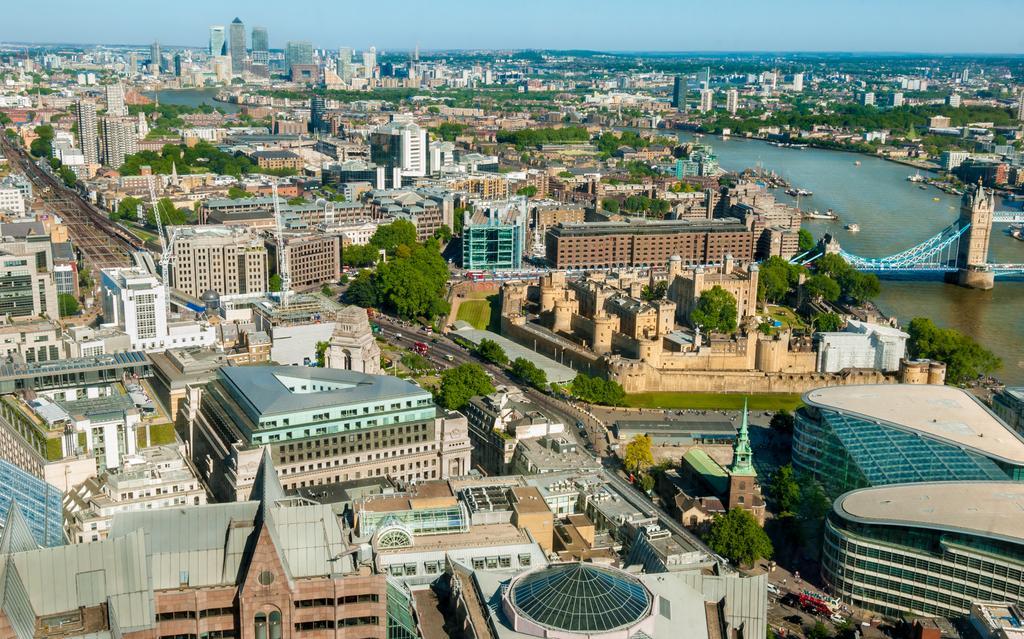How would you summarize this image in a sentence or two? This image is taken outdoors. At the top of the image there is the sky. In the middle of the image there are many buildings, houses and architectures. There are many trees and plants. There are many poles. There are many roads. Many vehicles are moving on the roads and a few are parked on the roads. On the right side of the image there is a bridge. There is a river with water and there are few boats on the river. 